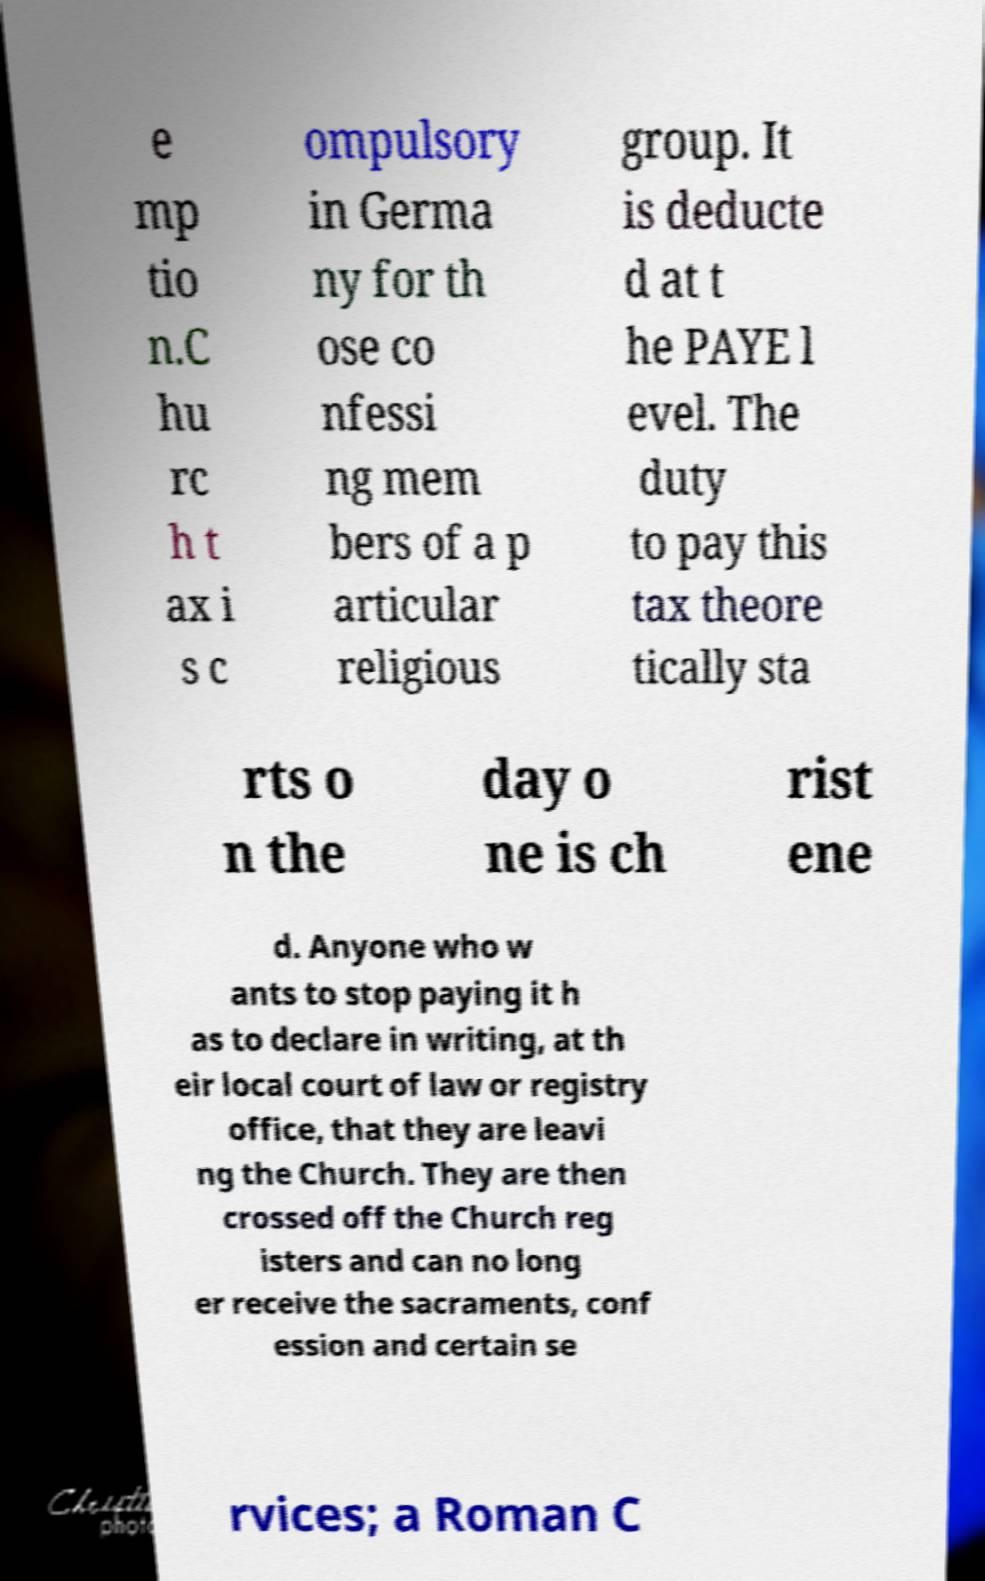There's text embedded in this image that I need extracted. Can you transcribe it verbatim? e mp tio n.C hu rc h t ax i s c ompulsory in Germa ny for th ose co nfessi ng mem bers of a p articular religious group. It is deducte d at t he PAYE l evel. The duty to pay this tax theore tically sta rts o n the day o ne is ch rist ene d. Anyone who w ants to stop paying it h as to declare in writing, at th eir local court of law or registry office, that they are leavi ng the Church. They are then crossed off the Church reg isters and can no long er receive the sacraments, conf ession and certain se rvices; a Roman C 